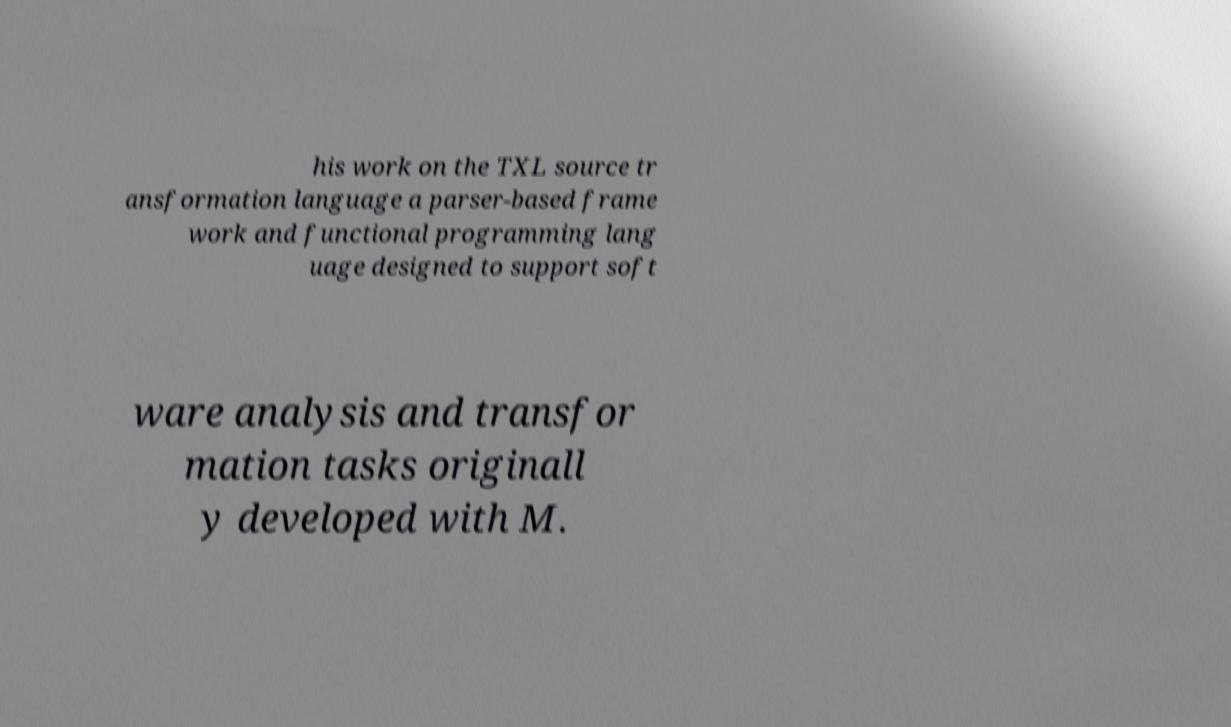For documentation purposes, I need the text within this image transcribed. Could you provide that? his work on the TXL source tr ansformation language a parser-based frame work and functional programming lang uage designed to support soft ware analysis and transfor mation tasks originall y developed with M. 